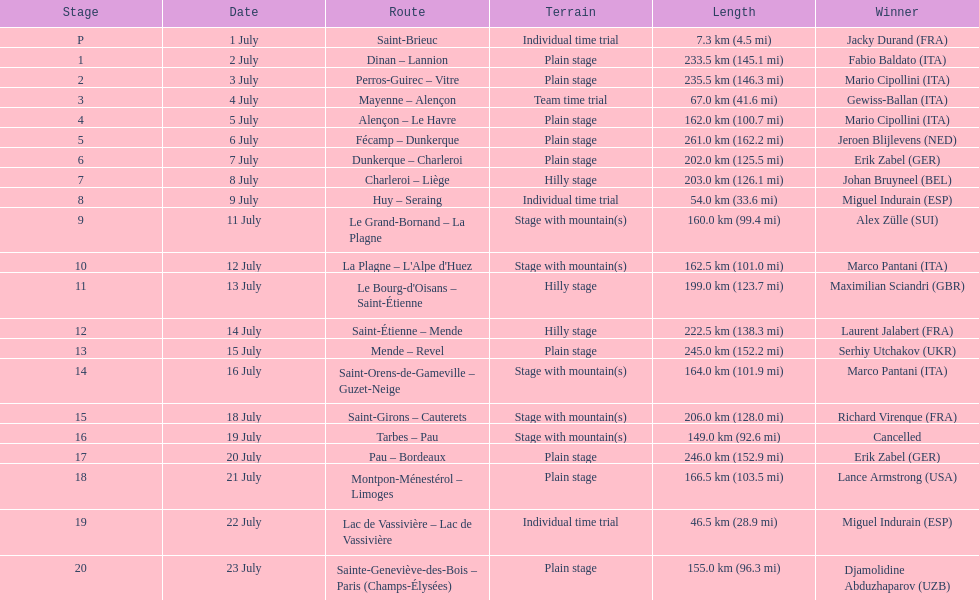How many consecutive km were raced on july 8th? 203.0 km (126.1 mi). 